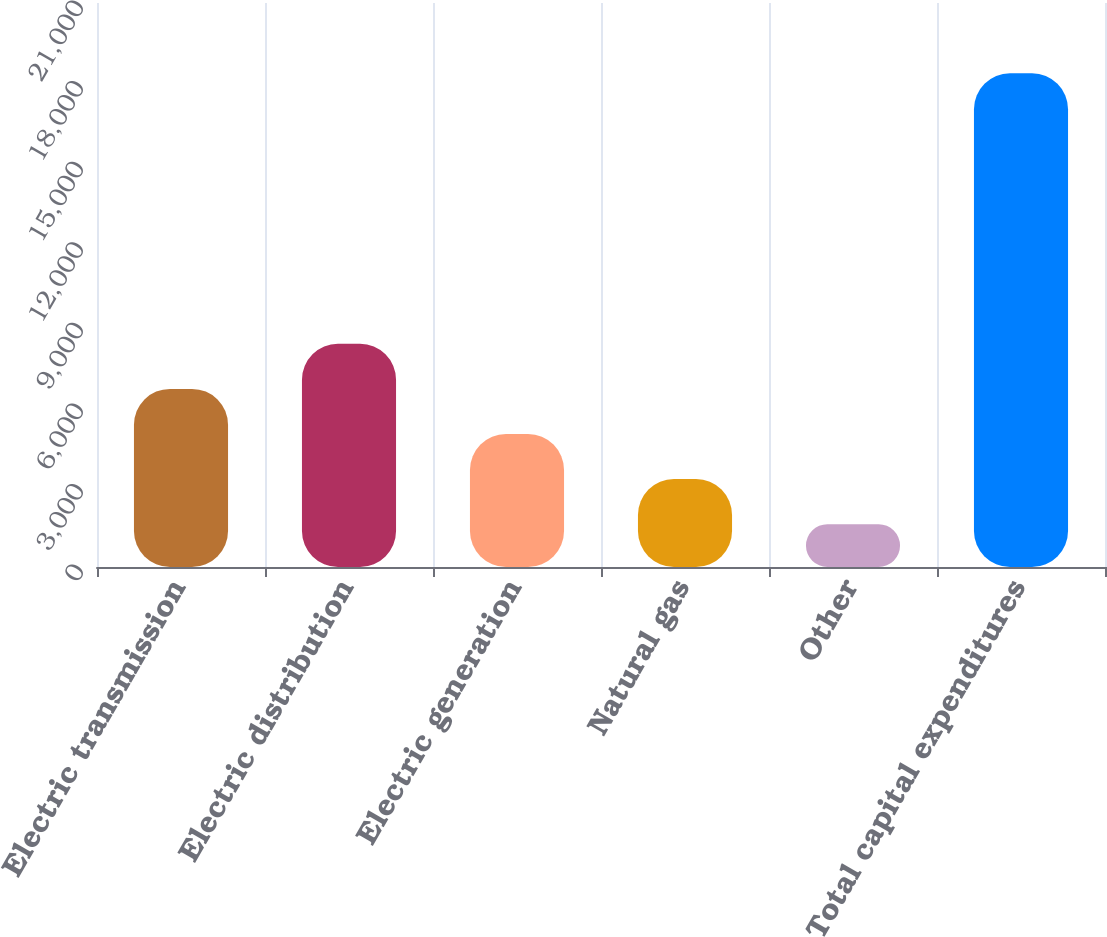<chart> <loc_0><loc_0><loc_500><loc_500><bar_chart><fcel>Electric transmission<fcel>Electric distribution<fcel>Electric generation<fcel>Natural gas<fcel>Other<fcel>Total capital expenditures<nl><fcel>6632<fcel>8311<fcel>4953<fcel>3274<fcel>1595<fcel>18385<nl></chart> 